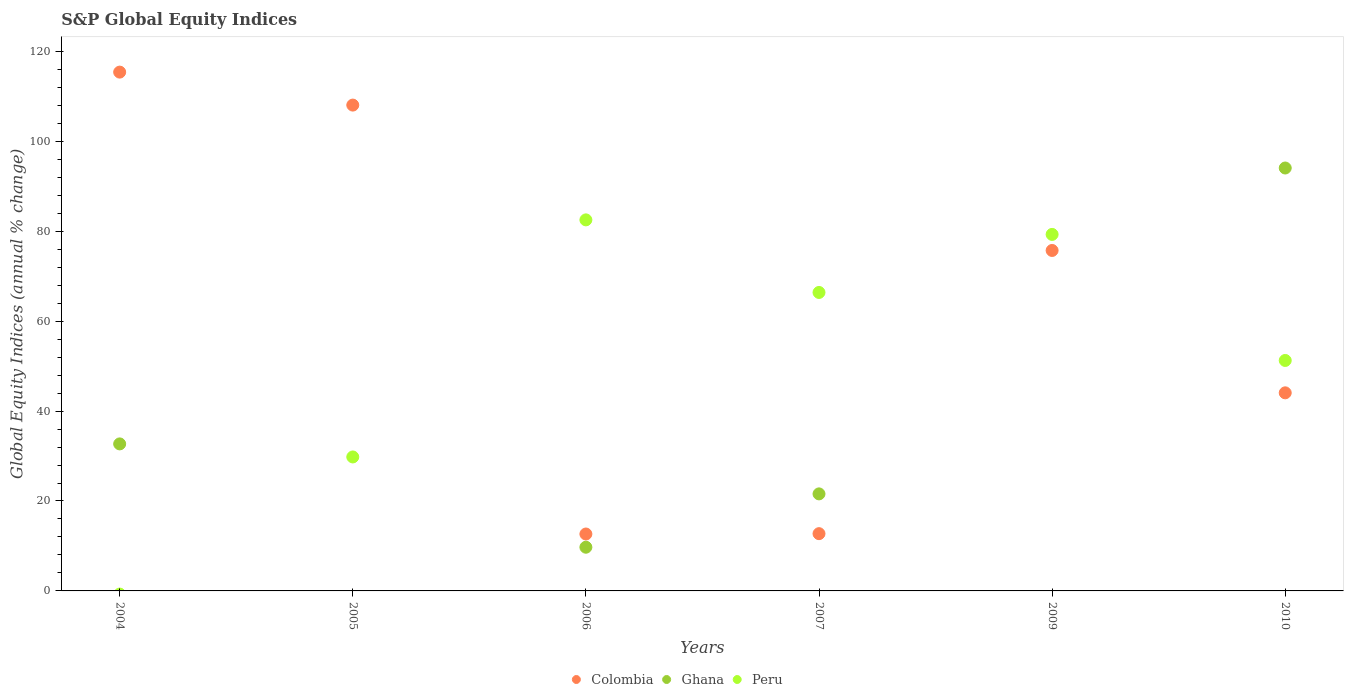How many different coloured dotlines are there?
Your response must be concise. 3. What is the global equity indices in Peru in 2005?
Your answer should be very brief. 29.8. Across all years, what is the maximum global equity indices in Ghana?
Make the answer very short. 94.06. In which year was the global equity indices in Ghana maximum?
Offer a terse response. 2010. What is the total global equity indices in Peru in the graph?
Offer a terse response. 309.26. What is the difference between the global equity indices in Ghana in 2004 and that in 2007?
Keep it short and to the point. 11.12. What is the difference between the global equity indices in Peru in 2006 and the global equity indices in Ghana in 2005?
Provide a short and direct response. 82.53. What is the average global equity indices in Peru per year?
Offer a very short reply. 51.54. In the year 2010, what is the difference between the global equity indices in Colombia and global equity indices in Peru?
Offer a very short reply. -7.2. In how many years, is the global equity indices in Peru greater than 64 %?
Ensure brevity in your answer.  3. What is the ratio of the global equity indices in Colombia in 2004 to that in 2007?
Your response must be concise. 9.06. Is the difference between the global equity indices in Colombia in 2006 and 2007 greater than the difference between the global equity indices in Peru in 2006 and 2007?
Make the answer very short. No. What is the difference between the highest and the second highest global equity indices in Colombia?
Provide a succinct answer. 7.33. What is the difference between the highest and the lowest global equity indices in Colombia?
Make the answer very short. 102.73. Is the sum of the global equity indices in Peru in 2006 and 2009 greater than the maximum global equity indices in Colombia across all years?
Your answer should be compact. Yes. Is it the case that in every year, the sum of the global equity indices in Peru and global equity indices in Ghana  is greater than the global equity indices in Colombia?
Make the answer very short. No. Does the global equity indices in Colombia monotonically increase over the years?
Ensure brevity in your answer.  No. Is the global equity indices in Colombia strictly greater than the global equity indices in Peru over the years?
Offer a terse response. No. Is the global equity indices in Ghana strictly less than the global equity indices in Colombia over the years?
Your answer should be compact. No. How many dotlines are there?
Offer a terse response. 3. How many years are there in the graph?
Your answer should be compact. 6. What is the difference between two consecutive major ticks on the Y-axis?
Your answer should be compact. 20. Are the values on the major ticks of Y-axis written in scientific E-notation?
Keep it short and to the point. No. Does the graph contain any zero values?
Your answer should be compact. Yes. How are the legend labels stacked?
Keep it short and to the point. Horizontal. What is the title of the graph?
Offer a terse response. S&P Global Equity Indices. What is the label or title of the Y-axis?
Make the answer very short. Global Equity Indices (annual % change). What is the Global Equity Indices (annual % change) in Colombia in 2004?
Your answer should be very brief. 115.39. What is the Global Equity Indices (annual % change) of Ghana in 2004?
Provide a succinct answer. 32.7. What is the Global Equity Indices (annual % change) in Colombia in 2005?
Your answer should be very brief. 108.06. What is the Global Equity Indices (annual % change) of Peru in 2005?
Give a very brief answer. 29.8. What is the Global Equity Indices (annual % change) of Colombia in 2006?
Give a very brief answer. 12.66. What is the Global Equity Indices (annual % change) of Ghana in 2006?
Your answer should be compact. 9.72. What is the Global Equity Indices (annual % change) in Peru in 2006?
Provide a short and direct response. 82.53. What is the Global Equity Indices (annual % change) of Colombia in 2007?
Offer a terse response. 12.74. What is the Global Equity Indices (annual % change) in Ghana in 2007?
Make the answer very short. 21.58. What is the Global Equity Indices (annual % change) in Peru in 2007?
Give a very brief answer. 66.38. What is the Global Equity Indices (annual % change) of Colombia in 2009?
Your answer should be compact. 75.72. What is the Global Equity Indices (annual % change) of Peru in 2009?
Make the answer very short. 79.29. What is the Global Equity Indices (annual % change) in Colombia in 2010?
Your answer should be very brief. 44.06. What is the Global Equity Indices (annual % change) in Ghana in 2010?
Make the answer very short. 94.06. What is the Global Equity Indices (annual % change) of Peru in 2010?
Your answer should be very brief. 51.26. Across all years, what is the maximum Global Equity Indices (annual % change) in Colombia?
Give a very brief answer. 115.39. Across all years, what is the maximum Global Equity Indices (annual % change) of Ghana?
Offer a terse response. 94.06. Across all years, what is the maximum Global Equity Indices (annual % change) in Peru?
Offer a very short reply. 82.53. Across all years, what is the minimum Global Equity Indices (annual % change) of Colombia?
Provide a succinct answer. 12.66. What is the total Global Equity Indices (annual % change) in Colombia in the graph?
Give a very brief answer. 368.62. What is the total Global Equity Indices (annual % change) of Ghana in the graph?
Your answer should be compact. 158.07. What is the total Global Equity Indices (annual % change) in Peru in the graph?
Offer a very short reply. 309.26. What is the difference between the Global Equity Indices (annual % change) of Colombia in 2004 and that in 2005?
Your answer should be very brief. 7.33. What is the difference between the Global Equity Indices (annual % change) of Colombia in 2004 and that in 2006?
Your response must be concise. 102.73. What is the difference between the Global Equity Indices (annual % change) of Ghana in 2004 and that in 2006?
Your response must be concise. 22.98. What is the difference between the Global Equity Indices (annual % change) in Colombia in 2004 and that in 2007?
Provide a succinct answer. 102.65. What is the difference between the Global Equity Indices (annual % change) in Ghana in 2004 and that in 2007?
Offer a terse response. 11.12. What is the difference between the Global Equity Indices (annual % change) of Colombia in 2004 and that in 2009?
Make the answer very short. 39.67. What is the difference between the Global Equity Indices (annual % change) of Colombia in 2004 and that in 2010?
Ensure brevity in your answer.  71.33. What is the difference between the Global Equity Indices (annual % change) in Ghana in 2004 and that in 2010?
Ensure brevity in your answer.  -61.36. What is the difference between the Global Equity Indices (annual % change) of Colombia in 2005 and that in 2006?
Make the answer very short. 95.4. What is the difference between the Global Equity Indices (annual % change) in Peru in 2005 and that in 2006?
Ensure brevity in your answer.  -52.73. What is the difference between the Global Equity Indices (annual % change) of Colombia in 2005 and that in 2007?
Your answer should be compact. 95.32. What is the difference between the Global Equity Indices (annual % change) of Peru in 2005 and that in 2007?
Offer a terse response. -36.59. What is the difference between the Global Equity Indices (annual % change) in Colombia in 2005 and that in 2009?
Ensure brevity in your answer.  32.33. What is the difference between the Global Equity Indices (annual % change) in Peru in 2005 and that in 2009?
Your answer should be very brief. -49.5. What is the difference between the Global Equity Indices (annual % change) in Colombia in 2005 and that in 2010?
Provide a succinct answer. 64. What is the difference between the Global Equity Indices (annual % change) of Peru in 2005 and that in 2010?
Offer a terse response. -21.46. What is the difference between the Global Equity Indices (annual % change) of Colombia in 2006 and that in 2007?
Your answer should be compact. -0.08. What is the difference between the Global Equity Indices (annual % change) in Ghana in 2006 and that in 2007?
Your answer should be very brief. -11.86. What is the difference between the Global Equity Indices (annual % change) in Peru in 2006 and that in 2007?
Give a very brief answer. 16.14. What is the difference between the Global Equity Indices (annual % change) in Colombia in 2006 and that in 2009?
Keep it short and to the point. -63.06. What is the difference between the Global Equity Indices (annual % change) of Peru in 2006 and that in 2009?
Give a very brief answer. 3.23. What is the difference between the Global Equity Indices (annual % change) of Colombia in 2006 and that in 2010?
Keep it short and to the point. -31.4. What is the difference between the Global Equity Indices (annual % change) in Ghana in 2006 and that in 2010?
Provide a short and direct response. -84.34. What is the difference between the Global Equity Indices (annual % change) of Peru in 2006 and that in 2010?
Offer a terse response. 31.27. What is the difference between the Global Equity Indices (annual % change) of Colombia in 2007 and that in 2009?
Offer a terse response. -62.99. What is the difference between the Global Equity Indices (annual % change) in Peru in 2007 and that in 2009?
Your response must be concise. -12.91. What is the difference between the Global Equity Indices (annual % change) of Colombia in 2007 and that in 2010?
Ensure brevity in your answer.  -31.32. What is the difference between the Global Equity Indices (annual % change) in Ghana in 2007 and that in 2010?
Provide a short and direct response. -72.48. What is the difference between the Global Equity Indices (annual % change) of Peru in 2007 and that in 2010?
Offer a very short reply. 15.12. What is the difference between the Global Equity Indices (annual % change) in Colombia in 2009 and that in 2010?
Your response must be concise. 31.66. What is the difference between the Global Equity Indices (annual % change) of Peru in 2009 and that in 2010?
Ensure brevity in your answer.  28.03. What is the difference between the Global Equity Indices (annual % change) in Colombia in 2004 and the Global Equity Indices (annual % change) in Peru in 2005?
Make the answer very short. 85.59. What is the difference between the Global Equity Indices (annual % change) in Ghana in 2004 and the Global Equity Indices (annual % change) in Peru in 2005?
Keep it short and to the point. 2.9. What is the difference between the Global Equity Indices (annual % change) of Colombia in 2004 and the Global Equity Indices (annual % change) of Ghana in 2006?
Give a very brief answer. 105.67. What is the difference between the Global Equity Indices (annual % change) in Colombia in 2004 and the Global Equity Indices (annual % change) in Peru in 2006?
Ensure brevity in your answer.  32.86. What is the difference between the Global Equity Indices (annual % change) of Ghana in 2004 and the Global Equity Indices (annual % change) of Peru in 2006?
Keep it short and to the point. -49.83. What is the difference between the Global Equity Indices (annual % change) in Colombia in 2004 and the Global Equity Indices (annual % change) in Ghana in 2007?
Your answer should be compact. 93.81. What is the difference between the Global Equity Indices (annual % change) in Colombia in 2004 and the Global Equity Indices (annual % change) in Peru in 2007?
Your answer should be compact. 49.01. What is the difference between the Global Equity Indices (annual % change) in Ghana in 2004 and the Global Equity Indices (annual % change) in Peru in 2007?
Your answer should be compact. -33.68. What is the difference between the Global Equity Indices (annual % change) of Colombia in 2004 and the Global Equity Indices (annual % change) of Peru in 2009?
Provide a succinct answer. 36.1. What is the difference between the Global Equity Indices (annual % change) of Ghana in 2004 and the Global Equity Indices (annual % change) of Peru in 2009?
Your response must be concise. -46.59. What is the difference between the Global Equity Indices (annual % change) in Colombia in 2004 and the Global Equity Indices (annual % change) in Ghana in 2010?
Provide a succinct answer. 21.33. What is the difference between the Global Equity Indices (annual % change) of Colombia in 2004 and the Global Equity Indices (annual % change) of Peru in 2010?
Your response must be concise. 64.13. What is the difference between the Global Equity Indices (annual % change) of Ghana in 2004 and the Global Equity Indices (annual % change) of Peru in 2010?
Offer a very short reply. -18.56. What is the difference between the Global Equity Indices (annual % change) of Colombia in 2005 and the Global Equity Indices (annual % change) of Ghana in 2006?
Offer a very short reply. 98.34. What is the difference between the Global Equity Indices (annual % change) of Colombia in 2005 and the Global Equity Indices (annual % change) of Peru in 2006?
Make the answer very short. 25.53. What is the difference between the Global Equity Indices (annual % change) in Colombia in 2005 and the Global Equity Indices (annual % change) in Ghana in 2007?
Make the answer very short. 86.47. What is the difference between the Global Equity Indices (annual % change) in Colombia in 2005 and the Global Equity Indices (annual % change) in Peru in 2007?
Your answer should be compact. 41.67. What is the difference between the Global Equity Indices (annual % change) of Colombia in 2005 and the Global Equity Indices (annual % change) of Peru in 2009?
Provide a succinct answer. 28.76. What is the difference between the Global Equity Indices (annual % change) of Colombia in 2005 and the Global Equity Indices (annual % change) of Ghana in 2010?
Your answer should be compact. 13.99. What is the difference between the Global Equity Indices (annual % change) of Colombia in 2005 and the Global Equity Indices (annual % change) of Peru in 2010?
Keep it short and to the point. 56.8. What is the difference between the Global Equity Indices (annual % change) in Colombia in 2006 and the Global Equity Indices (annual % change) in Ghana in 2007?
Make the answer very short. -8.93. What is the difference between the Global Equity Indices (annual % change) of Colombia in 2006 and the Global Equity Indices (annual % change) of Peru in 2007?
Your answer should be compact. -53.73. What is the difference between the Global Equity Indices (annual % change) in Ghana in 2006 and the Global Equity Indices (annual % change) in Peru in 2007?
Provide a short and direct response. -56.66. What is the difference between the Global Equity Indices (annual % change) in Colombia in 2006 and the Global Equity Indices (annual % change) in Peru in 2009?
Offer a very short reply. -66.63. What is the difference between the Global Equity Indices (annual % change) in Ghana in 2006 and the Global Equity Indices (annual % change) in Peru in 2009?
Offer a terse response. -69.57. What is the difference between the Global Equity Indices (annual % change) of Colombia in 2006 and the Global Equity Indices (annual % change) of Ghana in 2010?
Your response must be concise. -81.4. What is the difference between the Global Equity Indices (annual % change) of Colombia in 2006 and the Global Equity Indices (annual % change) of Peru in 2010?
Provide a succinct answer. -38.6. What is the difference between the Global Equity Indices (annual % change) of Ghana in 2006 and the Global Equity Indices (annual % change) of Peru in 2010?
Provide a short and direct response. -41.54. What is the difference between the Global Equity Indices (annual % change) of Colombia in 2007 and the Global Equity Indices (annual % change) of Peru in 2009?
Your response must be concise. -66.56. What is the difference between the Global Equity Indices (annual % change) of Ghana in 2007 and the Global Equity Indices (annual % change) of Peru in 2009?
Keep it short and to the point. -57.71. What is the difference between the Global Equity Indices (annual % change) in Colombia in 2007 and the Global Equity Indices (annual % change) in Ghana in 2010?
Provide a short and direct response. -81.33. What is the difference between the Global Equity Indices (annual % change) of Colombia in 2007 and the Global Equity Indices (annual % change) of Peru in 2010?
Make the answer very short. -38.52. What is the difference between the Global Equity Indices (annual % change) of Ghana in 2007 and the Global Equity Indices (annual % change) of Peru in 2010?
Your response must be concise. -29.68. What is the difference between the Global Equity Indices (annual % change) of Colombia in 2009 and the Global Equity Indices (annual % change) of Ghana in 2010?
Your answer should be compact. -18.34. What is the difference between the Global Equity Indices (annual % change) in Colombia in 2009 and the Global Equity Indices (annual % change) in Peru in 2010?
Keep it short and to the point. 24.46. What is the average Global Equity Indices (annual % change) in Colombia per year?
Your answer should be compact. 61.44. What is the average Global Equity Indices (annual % change) of Ghana per year?
Keep it short and to the point. 26.34. What is the average Global Equity Indices (annual % change) in Peru per year?
Your answer should be very brief. 51.54. In the year 2004, what is the difference between the Global Equity Indices (annual % change) of Colombia and Global Equity Indices (annual % change) of Ghana?
Your answer should be very brief. 82.69. In the year 2005, what is the difference between the Global Equity Indices (annual % change) of Colombia and Global Equity Indices (annual % change) of Peru?
Keep it short and to the point. 78.26. In the year 2006, what is the difference between the Global Equity Indices (annual % change) in Colombia and Global Equity Indices (annual % change) in Ghana?
Your response must be concise. 2.94. In the year 2006, what is the difference between the Global Equity Indices (annual % change) of Colombia and Global Equity Indices (annual % change) of Peru?
Keep it short and to the point. -69.87. In the year 2006, what is the difference between the Global Equity Indices (annual % change) in Ghana and Global Equity Indices (annual % change) in Peru?
Your answer should be compact. -72.81. In the year 2007, what is the difference between the Global Equity Indices (annual % change) of Colombia and Global Equity Indices (annual % change) of Ghana?
Make the answer very short. -8.85. In the year 2007, what is the difference between the Global Equity Indices (annual % change) in Colombia and Global Equity Indices (annual % change) in Peru?
Provide a succinct answer. -53.65. In the year 2007, what is the difference between the Global Equity Indices (annual % change) in Ghana and Global Equity Indices (annual % change) in Peru?
Give a very brief answer. -44.8. In the year 2009, what is the difference between the Global Equity Indices (annual % change) in Colombia and Global Equity Indices (annual % change) in Peru?
Offer a very short reply. -3.57. In the year 2010, what is the difference between the Global Equity Indices (annual % change) of Colombia and Global Equity Indices (annual % change) of Ghana?
Ensure brevity in your answer.  -50. In the year 2010, what is the difference between the Global Equity Indices (annual % change) of Colombia and Global Equity Indices (annual % change) of Peru?
Ensure brevity in your answer.  -7.2. In the year 2010, what is the difference between the Global Equity Indices (annual % change) in Ghana and Global Equity Indices (annual % change) in Peru?
Your answer should be compact. 42.8. What is the ratio of the Global Equity Indices (annual % change) in Colombia in 2004 to that in 2005?
Ensure brevity in your answer.  1.07. What is the ratio of the Global Equity Indices (annual % change) in Colombia in 2004 to that in 2006?
Give a very brief answer. 9.12. What is the ratio of the Global Equity Indices (annual % change) in Ghana in 2004 to that in 2006?
Keep it short and to the point. 3.36. What is the ratio of the Global Equity Indices (annual % change) of Colombia in 2004 to that in 2007?
Make the answer very short. 9.06. What is the ratio of the Global Equity Indices (annual % change) of Ghana in 2004 to that in 2007?
Provide a short and direct response. 1.52. What is the ratio of the Global Equity Indices (annual % change) of Colombia in 2004 to that in 2009?
Keep it short and to the point. 1.52. What is the ratio of the Global Equity Indices (annual % change) of Colombia in 2004 to that in 2010?
Offer a very short reply. 2.62. What is the ratio of the Global Equity Indices (annual % change) of Ghana in 2004 to that in 2010?
Keep it short and to the point. 0.35. What is the ratio of the Global Equity Indices (annual % change) of Colombia in 2005 to that in 2006?
Provide a succinct answer. 8.54. What is the ratio of the Global Equity Indices (annual % change) in Peru in 2005 to that in 2006?
Your response must be concise. 0.36. What is the ratio of the Global Equity Indices (annual % change) of Colombia in 2005 to that in 2007?
Ensure brevity in your answer.  8.48. What is the ratio of the Global Equity Indices (annual % change) of Peru in 2005 to that in 2007?
Ensure brevity in your answer.  0.45. What is the ratio of the Global Equity Indices (annual % change) of Colombia in 2005 to that in 2009?
Provide a short and direct response. 1.43. What is the ratio of the Global Equity Indices (annual % change) of Peru in 2005 to that in 2009?
Make the answer very short. 0.38. What is the ratio of the Global Equity Indices (annual % change) of Colombia in 2005 to that in 2010?
Give a very brief answer. 2.45. What is the ratio of the Global Equity Indices (annual % change) in Peru in 2005 to that in 2010?
Offer a terse response. 0.58. What is the ratio of the Global Equity Indices (annual % change) in Colombia in 2006 to that in 2007?
Ensure brevity in your answer.  0.99. What is the ratio of the Global Equity Indices (annual % change) of Ghana in 2006 to that in 2007?
Your response must be concise. 0.45. What is the ratio of the Global Equity Indices (annual % change) in Peru in 2006 to that in 2007?
Your response must be concise. 1.24. What is the ratio of the Global Equity Indices (annual % change) of Colombia in 2006 to that in 2009?
Your answer should be compact. 0.17. What is the ratio of the Global Equity Indices (annual % change) in Peru in 2006 to that in 2009?
Keep it short and to the point. 1.04. What is the ratio of the Global Equity Indices (annual % change) of Colombia in 2006 to that in 2010?
Give a very brief answer. 0.29. What is the ratio of the Global Equity Indices (annual % change) of Ghana in 2006 to that in 2010?
Make the answer very short. 0.1. What is the ratio of the Global Equity Indices (annual % change) of Peru in 2006 to that in 2010?
Offer a very short reply. 1.61. What is the ratio of the Global Equity Indices (annual % change) in Colombia in 2007 to that in 2009?
Ensure brevity in your answer.  0.17. What is the ratio of the Global Equity Indices (annual % change) of Peru in 2007 to that in 2009?
Provide a succinct answer. 0.84. What is the ratio of the Global Equity Indices (annual % change) in Colombia in 2007 to that in 2010?
Your answer should be very brief. 0.29. What is the ratio of the Global Equity Indices (annual % change) in Ghana in 2007 to that in 2010?
Offer a very short reply. 0.23. What is the ratio of the Global Equity Indices (annual % change) of Peru in 2007 to that in 2010?
Keep it short and to the point. 1.3. What is the ratio of the Global Equity Indices (annual % change) in Colombia in 2009 to that in 2010?
Give a very brief answer. 1.72. What is the ratio of the Global Equity Indices (annual % change) in Peru in 2009 to that in 2010?
Make the answer very short. 1.55. What is the difference between the highest and the second highest Global Equity Indices (annual % change) of Colombia?
Your answer should be very brief. 7.33. What is the difference between the highest and the second highest Global Equity Indices (annual % change) in Ghana?
Offer a very short reply. 61.36. What is the difference between the highest and the second highest Global Equity Indices (annual % change) in Peru?
Your response must be concise. 3.23. What is the difference between the highest and the lowest Global Equity Indices (annual % change) in Colombia?
Make the answer very short. 102.73. What is the difference between the highest and the lowest Global Equity Indices (annual % change) of Ghana?
Your response must be concise. 94.06. What is the difference between the highest and the lowest Global Equity Indices (annual % change) in Peru?
Offer a terse response. 82.53. 